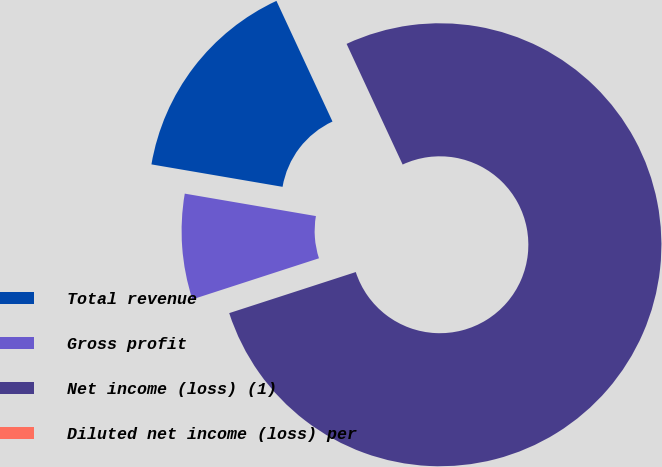Convert chart. <chart><loc_0><loc_0><loc_500><loc_500><pie_chart><fcel>Total revenue<fcel>Gross profit<fcel>Net income (loss) (1)<fcel>Diluted net income (loss) per<nl><fcel>15.38%<fcel>7.69%<fcel>76.92%<fcel>0.0%<nl></chart> 